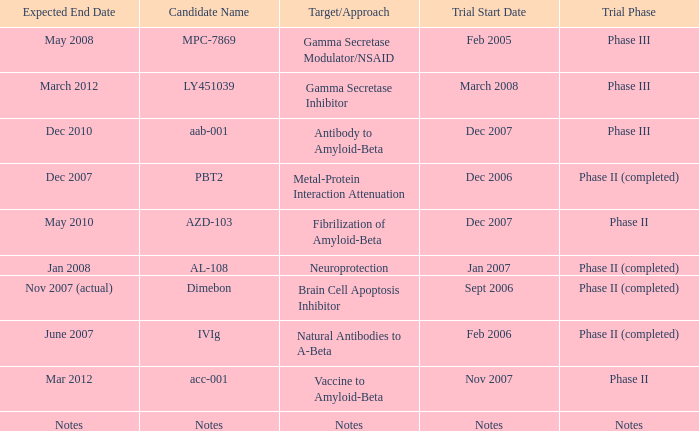What is Expected End Date, when Target/Approach is Notes? Notes. 